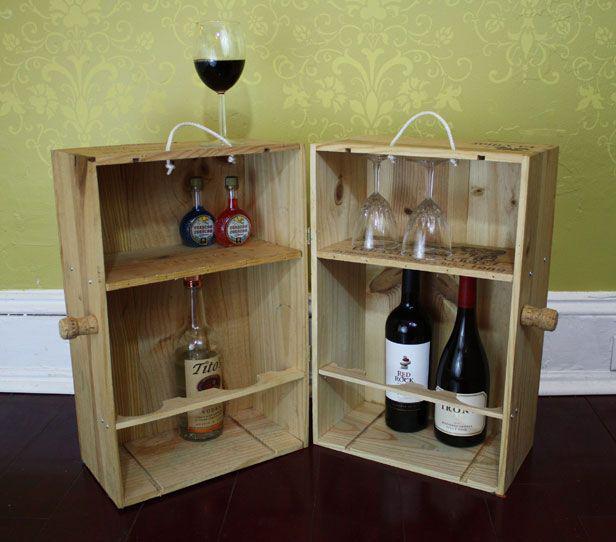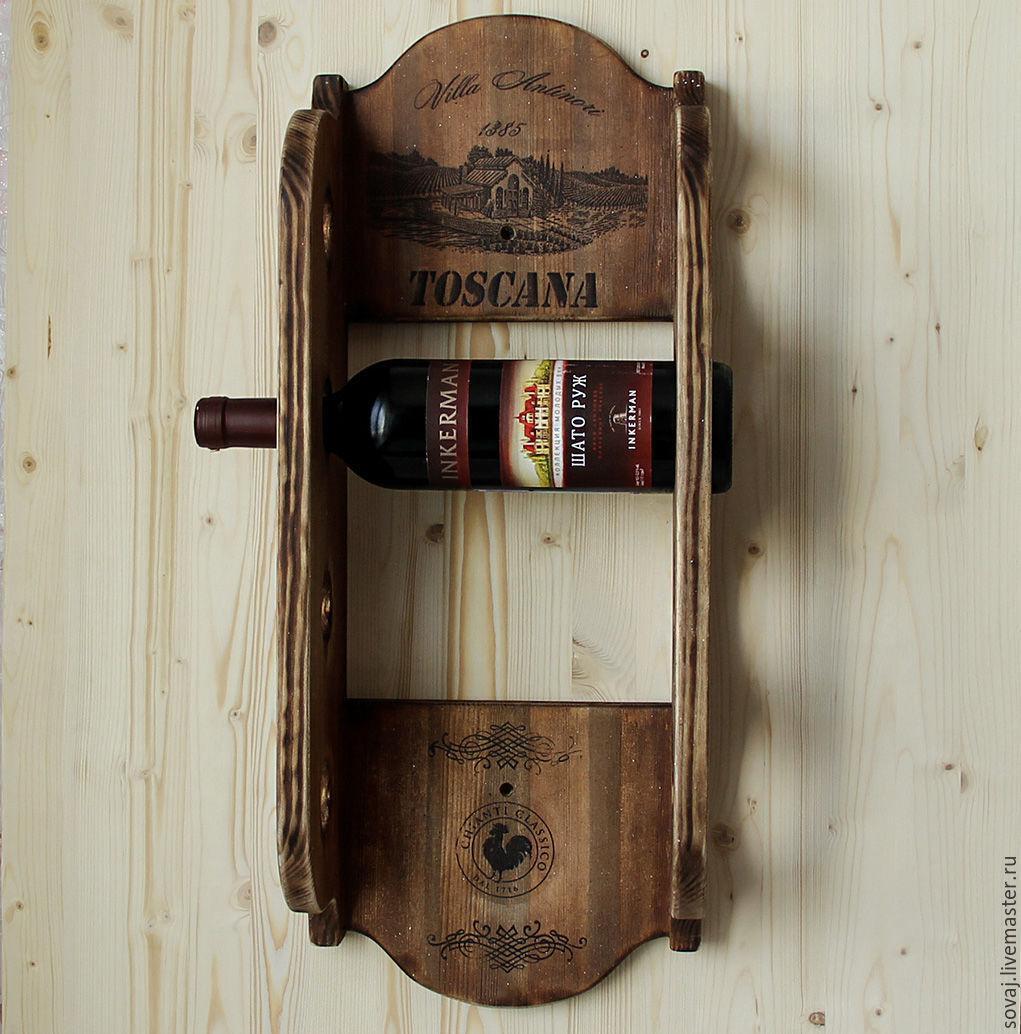The first image is the image on the left, the second image is the image on the right. For the images displayed, is the sentence "At least one wine bottle is being stored horizontally in a rack." factually correct? Answer yes or no. Yes. The first image is the image on the left, the second image is the image on the right. For the images displayed, is the sentence "In at least one image there is a brown chair next to a homemade bar." factually correct? Answer yes or no. No. 